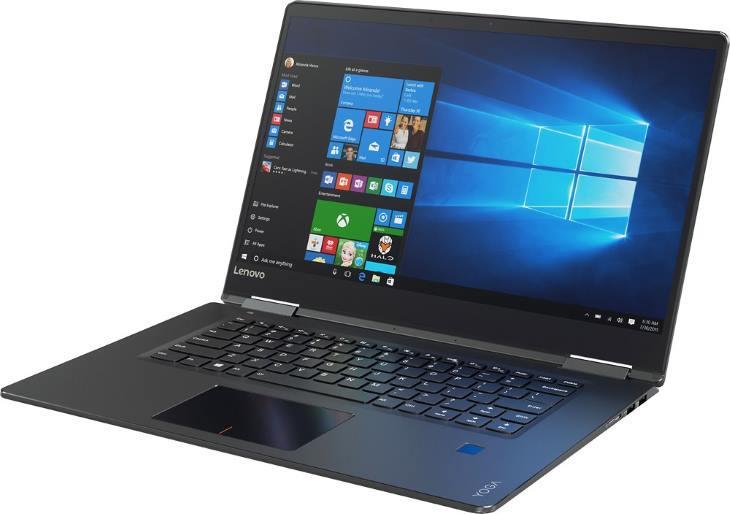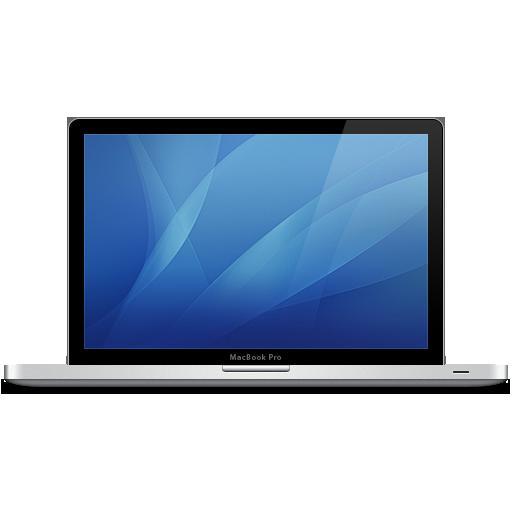The first image is the image on the left, the second image is the image on the right. For the images shown, is this caption "Both of the laptops are facing in the same direction." true? Answer yes or no. No. The first image is the image on the left, the second image is the image on the right. For the images shown, is this caption "Each image shows one opened laptop angled so the screen faces rightward." true? Answer yes or no. No. 